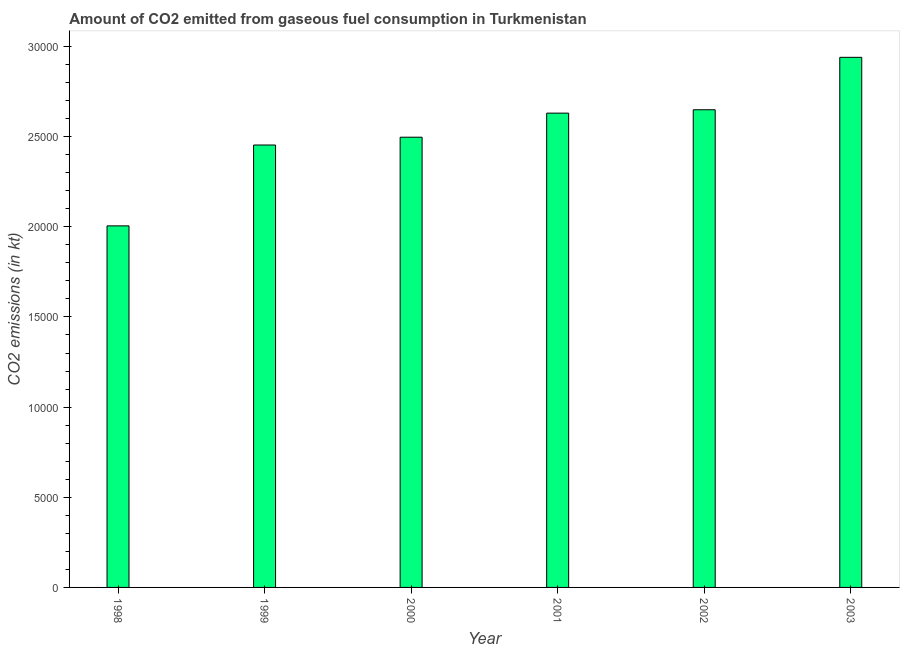Does the graph contain any zero values?
Your answer should be compact. No. Does the graph contain grids?
Your response must be concise. No. What is the title of the graph?
Give a very brief answer. Amount of CO2 emitted from gaseous fuel consumption in Turkmenistan. What is the label or title of the X-axis?
Ensure brevity in your answer.  Year. What is the label or title of the Y-axis?
Offer a terse response. CO2 emissions (in kt). What is the co2 emissions from gaseous fuel consumption in 1998?
Give a very brief answer. 2.01e+04. Across all years, what is the maximum co2 emissions from gaseous fuel consumption?
Offer a very short reply. 2.94e+04. Across all years, what is the minimum co2 emissions from gaseous fuel consumption?
Ensure brevity in your answer.  2.01e+04. In which year was the co2 emissions from gaseous fuel consumption maximum?
Provide a succinct answer. 2003. In which year was the co2 emissions from gaseous fuel consumption minimum?
Make the answer very short. 1998. What is the sum of the co2 emissions from gaseous fuel consumption?
Keep it short and to the point. 1.52e+05. What is the difference between the co2 emissions from gaseous fuel consumption in 2000 and 2001?
Your response must be concise. -1334.79. What is the average co2 emissions from gaseous fuel consumption per year?
Ensure brevity in your answer.  2.53e+04. What is the median co2 emissions from gaseous fuel consumption?
Your response must be concise. 2.56e+04. What is the ratio of the co2 emissions from gaseous fuel consumption in 1999 to that in 2001?
Your answer should be very brief. 0.93. What is the difference between the highest and the second highest co2 emissions from gaseous fuel consumption?
Ensure brevity in your answer.  2907.93. What is the difference between the highest and the lowest co2 emissions from gaseous fuel consumption?
Make the answer very short. 9347.18. How many bars are there?
Offer a terse response. 6. How many years are there in the graph?
Your response must be concise. 6. What is the difference between two consecutive major ticks on the Y-axis?
Keep it short and to the point. 5000. Are the values on the major ticks of Y-axis written in scientific E-notation?
Provide a succinct answer. No. What is the CO2 emissions (in kt) of 1998?
Your response must be concise. 2.01e+04. What is the CO2 emissions (in kt) of 1999?
Make the answer very short. 2.45e+04. What is the CO2 emissions (in kt) of 2000?
Your answer should be very brief. 2.50e+04. What is the CO2 emissions (in kt) in 2001?
Provide a succinct answer. 2.63e+04. What is the CO2 emissions (in kt) in 2002?
Make the answer very short. 2.65e+04. What is the CO2 emissions (in kt) in 2003?
Your answer should be very brief. 2.94e+04. What is the difference between the CO2 emissions (in kt) in 1998 and 1999?
Provide a succinct answer. -4484.74. What is the difference between the CO2 emissions (in kt) in 1998 and 2000?
Give a very brief answer. -4917.45. What is the difference between the CO2 emissions (in kt) in 1998 and 2001?
Give a very brief answer. -6252.23. What is the difference between the CO2 emissions (in kt) in 1998 and 2002?
Offer a terse response. -6439.25. What is the difference between the CO2 emissions (in kt) in 1998 and 2003?
Make the answer very short. -9347.18. What is the difference between the CO2 emissions (in kt) in 1999 and 2000?
Offer a very short reply. -432.71. What is the difference between the CO2 emissions (in kt) in 1999 and 2001?
Keep it short and to the point. -1767.49. What is the difference between the CO2 emissions (in kt) in 1999 and 2002?
Provide a short and direct response. -1954.51. What is the difference between the CO2 emissions (in kt) in 1999 and 2003?
Your response must be concise. -4862.44. What is the difference between the CO2 emissions (in kt) in 2000 and 2001?
Provide a short and direct response. -1334.79. What is the difference between the CO2 emissions (in kt) in 2000 and 2002?
Your answer should be compact. -1521.81. What is the difference between the CO2 emissions (in kt) in 2000 and 2003?
Keep it short and to the point. -4429.74. What is the difference between the CO2 emissions (in kt) in 2001 and 2002?
Give a very brief answer. -187.02. What is the difference between the CO2 emissions (in kt) in 2001 and 2003?
Your answer should be very brief. -3094.95. What is the difference between the CO2 emissions (in kt) in 2002 and 2003?
Offer a terse response. -2907.93. What is the ratio of the CO2 emissions (in kt) in 1998 to that in 1999?
Provide a succinct answer. 0.82. What is the ratio of the CO2 emissions (in kt) in 1998 to that in 2000?
Provide a succinct answer. 0.8. What is the ratio of the CO2 emissions (in kt) in 1998 to that in 2001?
Keep it short and to the point. 0.76. What is the ratio of the CO2 emissions (in kt) in 1998 to that in 2002?
Ensure brevity in your answer.  0.76. What is the ratio of the CO2 emissions (in kt) in 1998 to that in 2003?
Offer a terse response. 0.68. What is the ratio of the CO2 emissions (in kt) in 1999 to that in 2000?
Your answer should be very brief. 0.98. What is the ratio of the CO2 emissions (in kt) in 1999 to that in 2001?
Provide a succinct answer. 0.93. What is the ratio of the CO2 emissions (in kt) in 1999 to that in 2002?
Keep it short and to the point. 0.93. What is the ratio of the CO2 emissions (in kt) in 1999 to that in 2003?
Make the answer very short. 0.83. What is the ratio of the CO2 emissions (in kt) in 2000 to that in 2001?
Provide a succinct answer. 0.95. What is the ratio of the CO2 emissions (in kt) in 2000 to that in 2002?
Provide a short and direct response. 0.94. What is the ratio of the CO2 emissions (in kt) in 2000 to that in 2003?
Offer a very short reply. 0.85. What is the ratio of the CO2 emissions (in kt) in 2001 to that in 2002?
Offer a very short reply. 0.99. What is the ratio of the CO2 emissions (in kt) in 2001 to that in 2003?
Give a very brief answer. 0.9. What is the ratio of the CO2 emissions (in kt) in 2002 to that in 2003?
Make the answer very short. 0.9. 